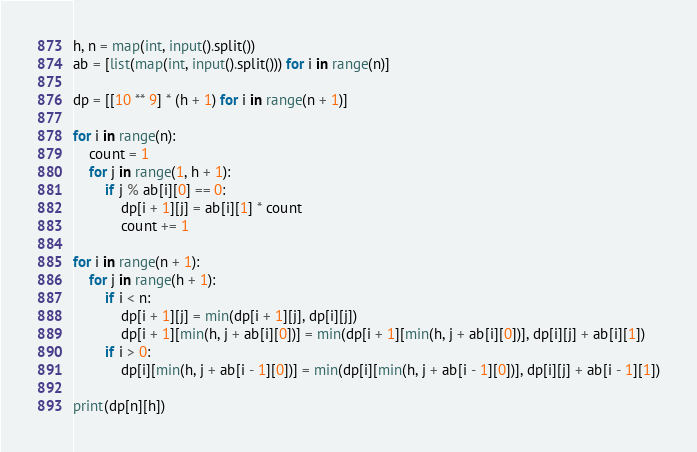<code> <loc_0><loc_0><loc_500><loc_500><_Python_>h, n = map(int, input().split())
ab = [list(map(int, input().split())) for i in range(n)]

dp = [[10 ** 9] * (h + 1) for i in range(n + 1)]

for i in range(n):
    count = 1
    for j in range(1, h + 1):
        if j % ab[i][0] == 0:
            dp[i + 1][j] = ab[i][1] * count
            count += 1

for i in range(n + 1):
    for j in range(h + 1):
        if i < n:
            dp[i + 1][j] = min(dp[i + 1][j], dp[i][j])
            dp[i + 1][min(h, j + ab[i][0])] = min(dp[i + 1][min(h, j + ab[i][0])], dp[i][j] + ab[i][1])
        if i > 0:
            dp[i][min(h, j + ab[i - 1][0])] = min(dp[i][min(h, j + ab[i - 1][0])], dp[i][j] + ab[i - 1][1])

print(dp[n][h])</code> 